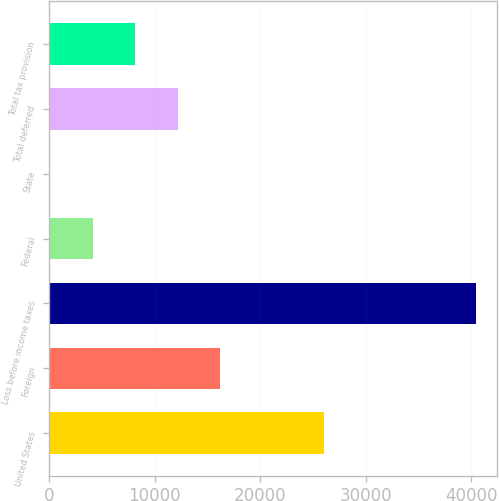Convert chart to OTSL. <chart><loc_0><loc_0><loc_500><loc_500><bar_chart><fcel>United States<fcel>Foreign<fcel>Loss before income taxes<fcel>Federal<fcel>State<fcel>Total deferred<fcel>Total tax provision<nl><fcel>26074<fcel>16213.4<fcel>40403<fcel>4118.6<fcel>87<fcel>12181.8<fcel>8150.2<nl></chart> 